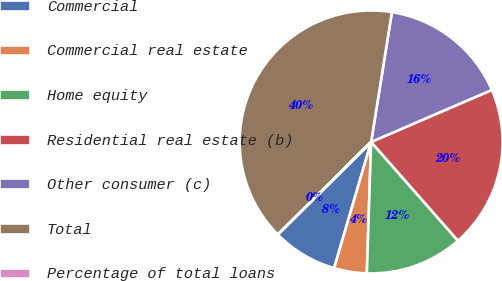Convert chart to OTSL. <chart><loc_0><loc_0><loc_500><loc_500><pie_chart><fcel>Commercial<fcel>Commercial real estate<fcel>Home equity<fcel>Residential real estate (b)<fcel>Other consumer (c)<fcel>Total<fcel>Percentage of total loans<nl><fcel>8.01%<fcel>4.02%<fcel>12.0%<fcel>19.99%<fcel>16.0%<fcel>39.95%<fcel>0.02%<nl></chart> 